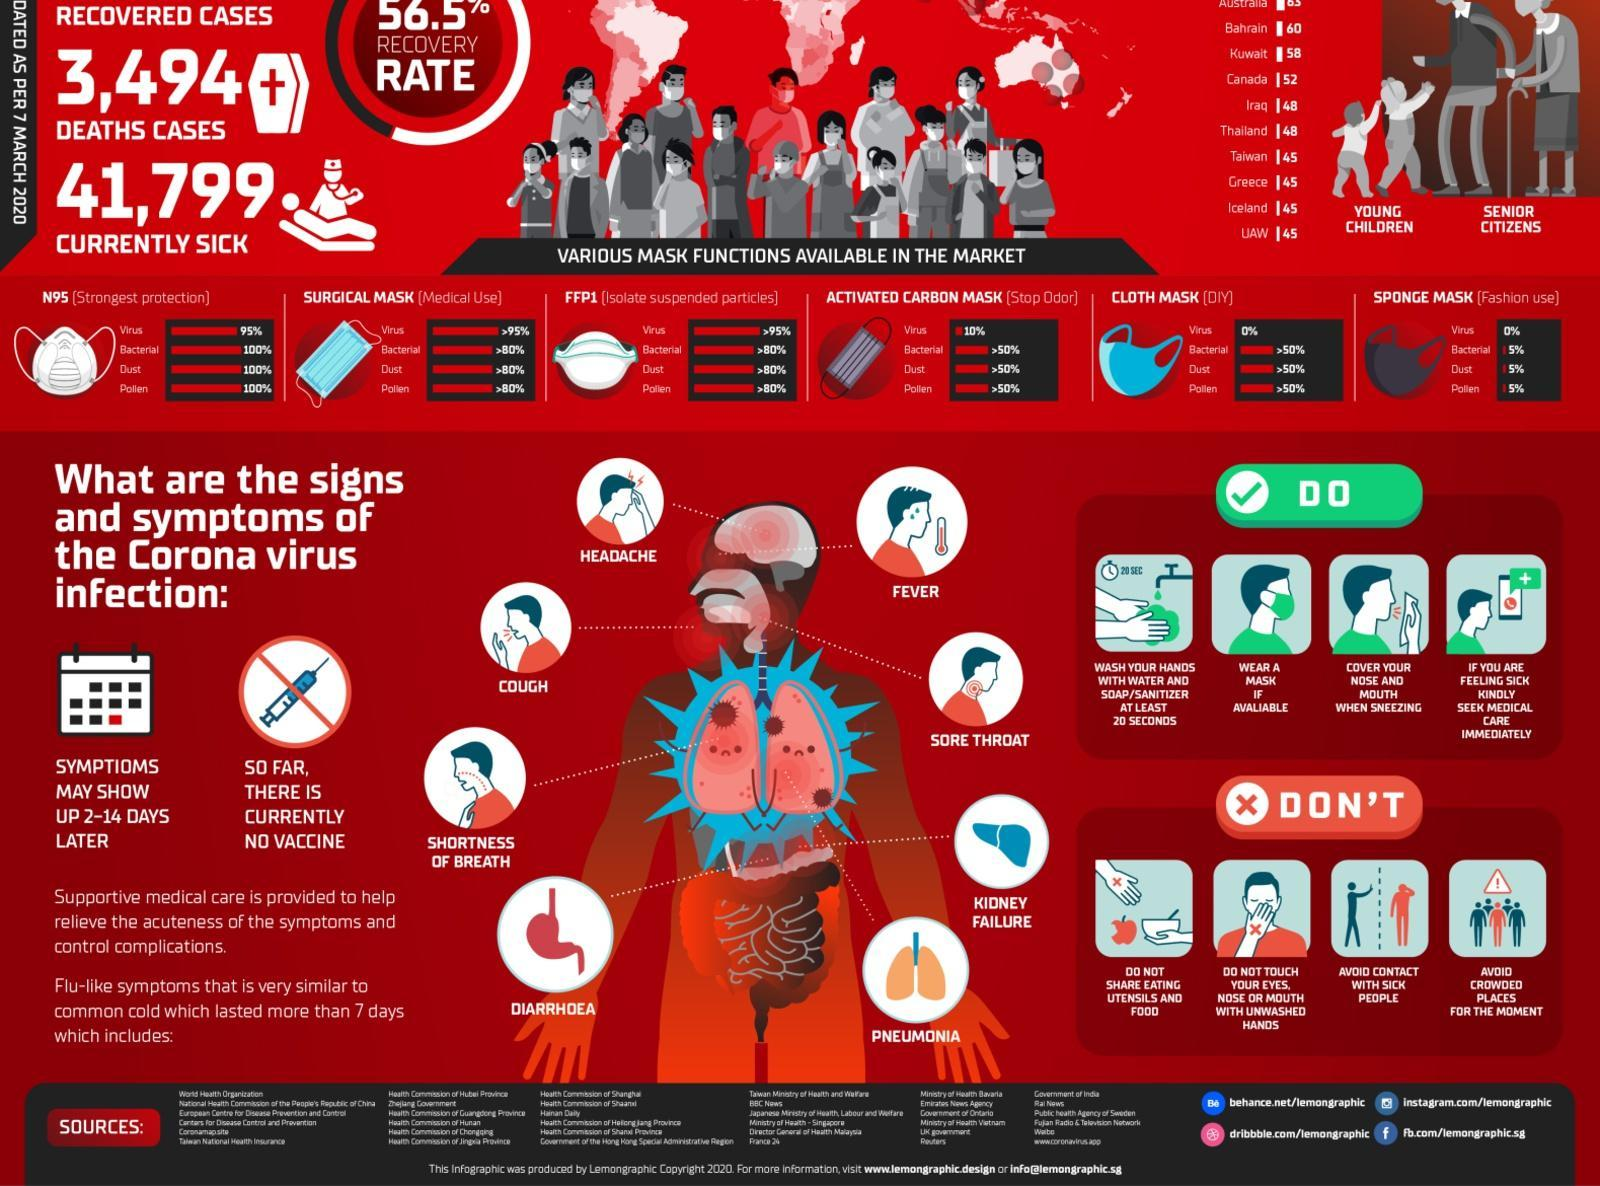Which mask offers the highest protection against bacteria?
Answer the question with a short phrase. N95 How many symptoms are shown in the image? 8 Which offers better protection against bacteria - cloth mask or sponge mask? Cloth mask Which mask offers 10% protection against virus? Activated carbon mask How many types of masks are shown ? 6 When do symptoms of Corona virus appear? 2-14 days later 